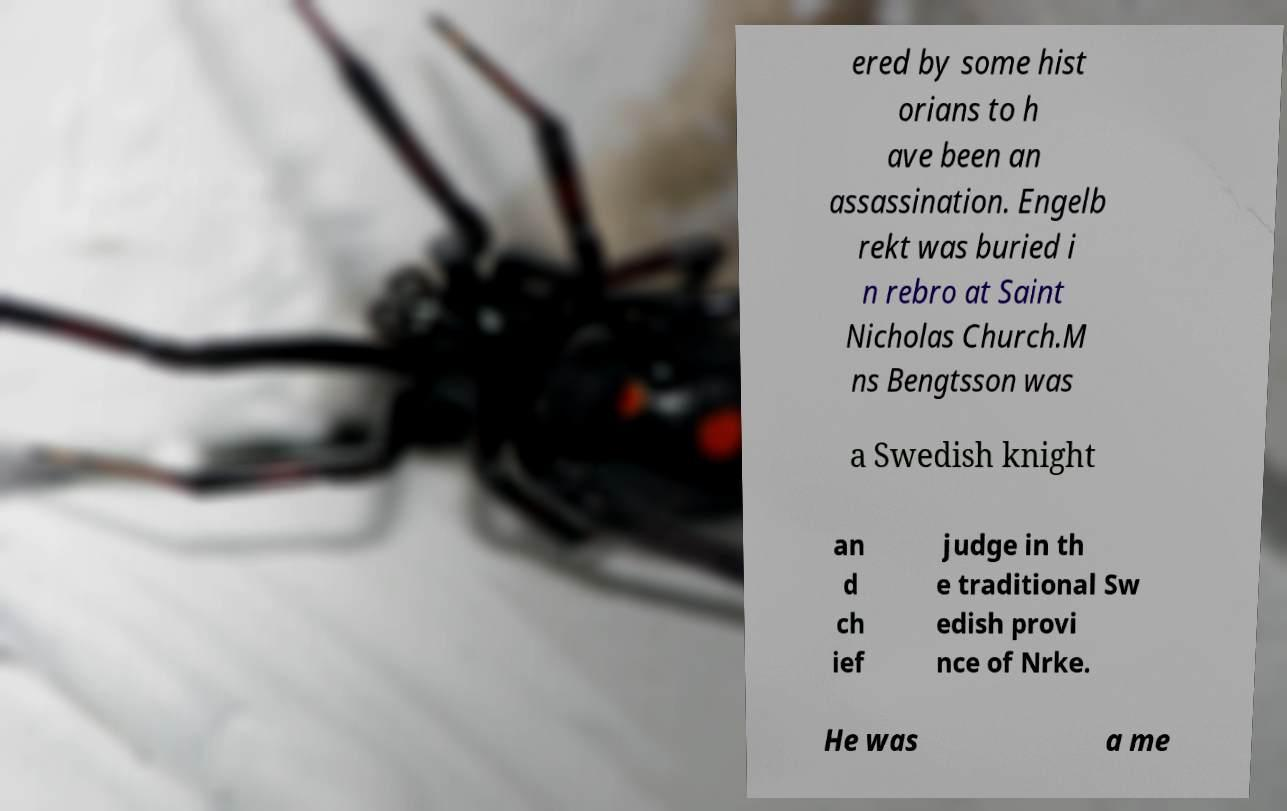I need the written content from this picture converted into text. Can you do that? ered by some hist orians to h ave been an assassination. Engelb rekt was buried i n rebro at Saint Nicholas Church.M ns Bengtsson was a Swedish knight an d ch ief judge in th e traditional Sw edish provi nce of Nrke. He was a me 